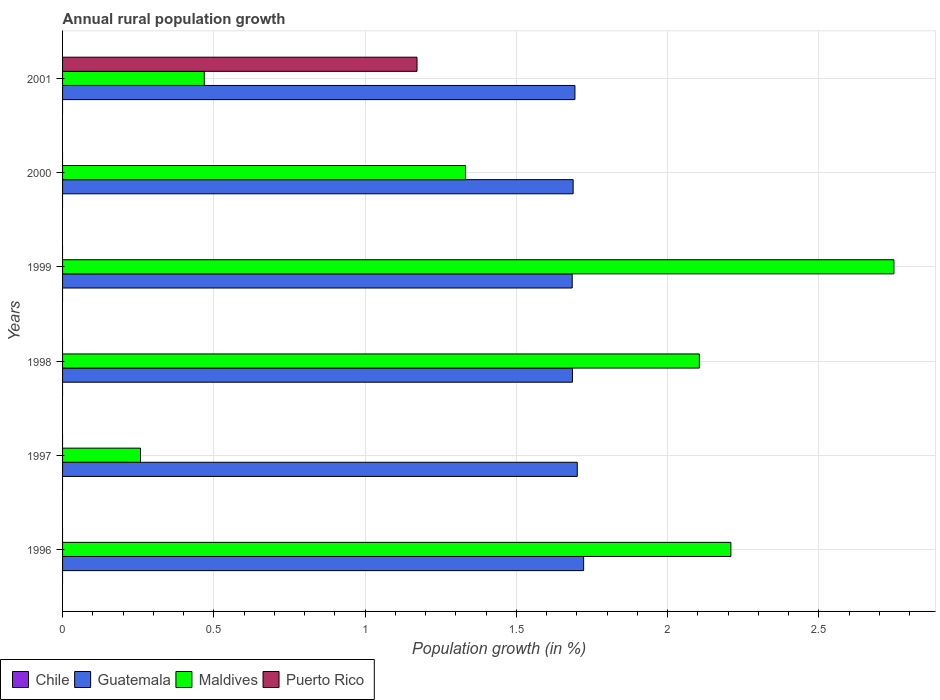How many different coloured bars are there?
Provide a succinct answer. 3. How many bars are there on the 5th tick from the top?
Ensure brevity in your answer.  2. How many bars are there on the 1st tick from the bottom?
Your answer should be very brief. 2. In how many cases, is the number of bars for a given year not equal to the number of legend labels?
Your response must be concise. 6. Across all years, what is the maximum percentage of rural population growth in Maldives?
Provide a short and direct response. 2.75. Across all years, what is the minimum percentage of rural population growth in Chile?
Your response must be concise. 0. In which year was the percentage of rural population growth in Puerto Rico maximum?
Your answer should be very brief. 2001. What is the total percentage of rural population growth in Guatemala in the graph?
Ensure brevity in your answer.  10.18. What is the difference between the percentage of rural population growth in Guatemala in 1997 and that in 1998?
Make the answer very short. 0.02. What is the difference between the percentage of rural population growth in Puerto Rico in 1996 and the percentage of rural population growth in Guatemala in 1999?
Your response must be concise. -1.68. What is the average percentage of rural population growth in Puerto Rico per year?
Your response must be concise. 0.2. In the year 1997, what is the difference between the percentage of rural population growth in Guatemala and percentage of rural population growth in Maldives?
Provide a succinct answer. 1.44. In how many years, is the percentage of rural population growth in Chile greater than 2.1 %?
Your answer should be very brief. 0. What is the ratio of the percentage of rural population growth in Maldives in 1996 to that in 1998?
Ensure brevity in your answer.  1.05. Is the percentage of rural population growth in Maldives in 1996 less than that in 1997?
Offer a terse response. No. Is the difference between the percentage of rural population growth in Guatemala in 1996 and 1998 greater than the difference between the percentage of rural population growth in Maldives in 1996 and 1998?
Your answer should be very brief. No. What is the difference between the highest and the second highest percentage of rural population growth in Guatemala?
Your answer should be compact. 0.02. What is the difference between the highest and the lowest percentage of rural population growth in Guatemala?
Make the answer very short. 0.04. Is the sum of the percentage of rural population growth in Guatemala in 1998 and 2001 greater than the maximum percentage of rural population growth in Puerto Rico across all years?
Offer a very short reply. Yes. Is it the case that in every year, the sum of the percentage of rural population growth in Chile and percentage of rural population growth in Maldives is greater than the sum of percentage of rural population growth in Guatemala and percentage of rural population growth in Puerto Rico?
Offer a very short reply. No. Are all the bars in the graph horizontal?
Keep it short and to the point. Yes. Are the values on the major ticks of X-axis written in scientific E-notation?
Provide a succinct answer. No. Does the graph contain any zero values?
Give a very brief answer. Yes. Does the graph contain grids?
Offer a very short reply. Yes. Where does the legend appear in the graph?
Offer a terse response. Bottom left. What is the title of the graph?
Your answer should be compact. Annual rural population growth. Does "Middle East & North Africa (developing only)" appear as one of the legend labels in the graph?
Keep it short and to the point. No. What is the label or title of the X-axis?
Keep it short and to the point. Population growth (in %). What is the label or title of the Y-axis?
Keep it short and to the point. Years. What is the Population growth (in %) of Guatemala in 1996?
Your answer should be very brief. 1.72. What is the Population growth (in %) in Maldives in 1996?
Make the answer very short. 2.21. What is the Population growth (in %) of Chile in 1997?
Your response must be concise. 0. What is the Population growth (in %) in Guatemala in 1997?
Your answer should be very brief. 1.7. What is the Population growth (in %) of Maldives in 1997?
Make the answer very short. 0.26. What is the Population growth (in %) of Puerto Rico in 1997?
Offer a very short reply. 0. What is the Population growth (in %) in Guatemala in 1998?
Provide a succinct answer. 1.69. What is the Population growth (in %) in Maldives in 1998?
Provide a succinct answer. 2.11. What is the Population growth (in %) in Chile in 1999?
Provide a succinct answer. 0. What is the Population growth (in %) of Guatemala in 1999?
Your answer should be very brief. 1.68. What is the Population growth (in %) of Maldives in 1999?
Give a very brief answer. 2.75. What is the Population growth (in %) of Puerto Rico in 1999?
Ensure brevity in your answer.  0. What is the Population growth (in %) of Guatemala in 2000?
Provide a short and direct response. 1.69. What is the Population growth (in %) of Maldives in 2000?
Offer a very short reply. 1.33. What is the Population growth (in %) in Puerto Rico in 2000?
Offer a terse response. 0. What is the Population growth (in %) in Chile in 2001?
Offer a very short reply. 0. What is the Population growth (in %) in Guatemala in 2001?
Provide a succinct answer. 1.69. What is the Population growth (in %) of Maldives in 2001?
Provide a short and direct response. 0.47. What is the Population growth (in %) of Puerto Rico in 2001?
Keep it short and to the point. 1.17. Across all years, what is the maximum Population growth (in %) in Guatemala?
Provide a short and direct response. 1.72. Across all years, what is the maximum Population growth (in %) of Maldives?
Ensure brevity in your answer.  2.75. Across all years, what is the maximum Population growth (in %) of Puerto Rico?
Make the answer very short. 1.17. Across all years, what is the minimum Population growth (in %) in Guatemala?
Ensure brevity in your answer.  1.68. Across all years, what is the minimum Population growth (in %) of Maldives?
Give a very brief answer. 0.26. What is the total Population growth (in %) of Chile in the graph?
Offer a terse response. 0. What is the total Population growth (in %) of Guatemala in the graph?
Ensure brevity in your answer.  10.18. What is the total Population growth (in %) of Maldives in the graph?
Ensure brevity in your answer.  9.12. What is the total Population growth (in %) in Puerto Rico in the graph?
Provide a succinct answer. 1.17. What is the difference between the Population growth (in %) in Guatemala in 1996 and that in 1997?
Offer a very short reply. 0.02. What is the difference between the Population growth (in %) in Maldives in 1996 and that in 1997?
Keep it short and to the point. 1.95. What is the difference between the Population growth (in %) of Guatemala in 1996 and that in 1998?
Your answer should be compact. 0.04. What is the difference between the Population growth (in %) of Maldives in 1996 and that in 1998?
Offer a terse response. 0.1. What is the difference between the Population growth (in %) in Guatemala in 1996 and that in 1999?
Your answer should be very brief. 0.04. What is the difference between the Population growth (in %) of Maldives in 1996 and that in 1999?
Offer a very short reply. -0.54. What is the difference between the Population growth (in %) in Guatemala in 1996 and that in 2000?
Your answer should be very brief. 0.03. What is the difference between the Population growth (in %) in Maldives in 1996 and that in 2000?
Your answer should be compact. 0.88. What is the difference between the Population growth (in %) in Guatemala in 1996 and that in 2001?
Offer a very short reply. 0.03. What is the difference between the Population growth (in %) in Maldives in 1996 and that in 2001?
Your answer should be compact. 1.74. What is the difference between the Population growth (in %) of Guatemala in 1997 and that in 1998?
Your answer should be very brief. 0.02. What is the difference between the Population growth (in %) in Maldives in 1997 and that in 1998?
Keep it short and to the point. -1.85. What is the difference between the Population growth (in %) of Guatemala in 1997 and that in 1999?
Offer a very short reply. 0.02. What is the difference between the Population growth (in %) of Maldives in 1997 and that in 1999?
Your response must be concise. -2.49. What is the difference between the Population growth (in %) of Guatemala in 1997 and that in 2000?
Give a very brief answer. 0.01. What is the difference between the Population growth (in %) in Maldives in 1997 and that in 2000?
Keep it short and to the point. -1.07. What is the difference between the Population growth (in %) of Guatemala in 1997 and that in 2001?
Offer a terse response. 0.01. What is the difference between the Population growth (in %) of Maldives in 1997 and that in 2001?
Provide a short and direct response. -0.21. What is the difference between the Population growth (in %) of Guatemala in 1998 and that in 1999?
Provide a succinct answer. 0. What is the difference between the Population growth (in %) of Maldives in 1998 and that in 1999?
Keep it short and to the point. -0.64. What is the difference between the Population growth (in %) in Guatemala in 1998 and that in 2000?
Your answer should be compact. -0. What is the difference between the Population growth (in %) of Maldives in 1998 and that in 2000?
Keep it short and to the point. 0.77. What is the difference between the Population growth (in %) in Guatemala in 1998 and that in 2001?
Your response must be concise. -0.01. What is the difference between the Population growth (in %) in Maldives in 1998 and that in 2001?
Your answer should be very brief. 1.64. What is the difference between the Population growth (in %) in Guatemala in 1999 and that in 2000?
Provide a succinct answer. -0. What is the difference between the Population growth (in %) of Maldives in 1999 and that in 2000?
Provide a short and direct response. 1.42. What is the difference between the Population growth (in %) in Guatemala in 1999 and that in 2001?
Offer a very short reply. -0.01. What is the difference between the Population growth (in %) in Maldives in 1999 and that in 2001?
Ensure brevity in your answer.  2.28. What is the difference between the Population growth (in %) of Guatemala in 2000 and that in 2001?
Offer a very short reply. -0.01. What is the difference between the Population growth (in %) in Maldives in 2000 and that in 2001?
Your answer should be very brief. 0.86. What is the difference between the Population growth (in %) of Guatemala in 1996 and the Population growth (in %) of Maldives in 1997?
Offer a terse response. 1.47. What is the difference between the Population growth (in %) of Guatemala in 1996 and the Population growth (in %) of Maldives in 1998?
Give a very brief answer. -0.38. What is the difference between the Population growth (in %) of Guatemala in 1996 and the Population growth (in %) of Maldives in 1999?
Your response must be concise. -1.03. What is the difference between the Population growth (in %) of Guatemala in 1996 and the Population growth (in %) of Maldives in 2000?
Ensure brevity in your answer.  0.39. What is the difference between the Population growth (in %) in Guatemala in 1996 and the Population growth (in %) in Maldives in 2001?
Provide a succinct answer. 1.25. What is the difference between the Population growth (in %) in Guatemala in 1996 and the Population growth (in %) in Puerto Rico in 2001?
Give a very brief answer. 0.55. What is the difference between the Population growth (in %) of Maldives in 1996 and the Population growth (in %) of Puerto Rico in 2001?
Your response must be concise. 1.04. What is the difference between the Population growth (in %) of Guatemala in 1997 and the Population growth (in %) of Maldives in 1998?
Your response must be concise. -0.4. What is the difference between the Population growth (in %) of Guatemala in 1997 and the Population growth (in %) of Maldives in 1999?
Your answer should be compact. -1.05. What is the difference between the Population growth (in %) of Guatemala in 1997 and the Population growth (in %) of Maldives in 2000?
Provide a succinct answer. 0.37. What is the difference between the Population growth (in %) of Guatemala in 1997 and the Population growth (in %) of Maldives in 2001?
Offer a very short reply. 1.23. What is the difference between the Population growth (in %) in Guatemala in 1997 and the Population growth (in %) in Puerto Rico in 2001?
Keep it short and to the point. 0.53. What is the difference between the Population growth (in %) in Maldives in 1997 and the Population growth (in %) in Puerto Rico in 2001?
Give a very brief answer. -0.91. What is the difference between the Population growth (in %) of Guatemala in 1998 and the Population growth (in %) of Maldives in 1999?
Your response must be concise. -1.06. What is the difference between the Population growth (in %) of Guatemala in 1998 and the Population growth (in %) of Maldives in 2000?
Your response must be concise. 0.35. What is the difference between the Population growth (in %) in Guatemala in 1998 and the Population growth (in %) in Maldives in 2001?
Your response must be concise. 1.22. What is the difference between the Population growth (in %) of Guatemala in 1998 and the Population growth (in %) of Puerto Rico in 2001?
Your answer should be very brief. 0.51. What is the difference between the Population growth (in %) in Maldives in 1998 and the Population growth (in %) in Puerto Rico in 2001?
Offer a very short reply. 0.93. What is the difference between the Population growth (in %) of Guatemala in 1999 and the Population growth (in %) of Maldives in 2000?
Offer a very short reply. 0.35. What is the difference between the Population growth (in %) in Guatemala in 1999 and the Population growth (in %) in Maldives in 2001?
Offer a very short reply. 1.22. What is the difference between the Population growth (in %) of Guatemala in 1999 and the Population growth (in %) of Puerto Rico in 2001?
Your response must be concise. 0.51. What is the difference between the Population growth (in %) of Maldives in 1999 and the Population growth (in %) of Puerto Rico in 2001?
Provide a short and direct response. 1.58. What is the difference between the Population growth (in %) in Guatemala in 2000 and the Population growth (in %) in Maldives in 2001?
Make the answer very short. 1.22. What is the difference between the Population growth (in %) in Guatemala in 2000 and the Population growth (in %) in Puerto Rico in 2001?
Provide a succinct answer. 0.52. What is the difference between the Population growth (in %) of Maldives in 2000 and the Population growth (in %) of Puerto Rico in 2001?
Provide a succinct answer. 0.16. What is the average Population growth (in %) of Guatemala per year?
Make the answer very short. 1.7. What is the average Population growth (in %) in Maldives per year?
Offer a very short reply. 1.52. What is the average Population growth (in %) of Puerto Rico per year?
Provide a short and direct response. 0.2. In the year 1996, what is the difference between the Population growth (in %) in Guatemala and Population growth (in %) in Maldives?
Provide a succinct answer. -0.49. In the year 1997, what is the difference between the Population growth (in %) in Guatemala and Population growth (in %) in Maldives?
Provide a succinct answer. 1.44. In the year 1998, what is the difference between the Population growth (in %) in Guatemala and Population growth (in %) in Maldives?
Offer a very short reply. -0.42. In the year 1999, what is the difference between the Population growth (in %) of Guatemala and Population growth (in %) of Maldives?
Offer a very short reply. -1.06. In the year 2000, what is the difference between the Population growth (in %) of Guatemala and Population growth (in %) of Maldives?
Your answer should be compact. 0.36. In the year 2001, what is the difference between the Population growth (in %) in Guatemala and Population growth (in %) in Maldives?
Ensure brevity in your answer.  1.23. In the year 2001, what is the difference between the Population growth (in %) in Guatemala and Population growth (in %) in Puerto Rico?
Your answer should be very brief. 0.52. In the year 2001, what is the difference between the Population growth (in %) in Maldives and Population growth (in %) in Puerto Rico?
Offer a very short reply. -0.7. What is the ratio of the Population growth (in %) in Guatemala in 1996 to that in 1997?
Provide a short and direct response. 1.01. What is the ratio of the Population growth (in %) in Maldives in 1996 to that in 1997?
Keep it short and to the point. 8.58. What is the ratio of the Population growth (in %) of Guatemala in 1996 to that in 1998?
Offer a terse response. 1.02. What is the ratio of the Population growth (in %) of Maldives in 1996 to that in 1998?
Offer a terse response. 1.05. What is the ratio of the Population growth (in %) in Guatemala in 1996 to that in 1999?
Provide a succinct answer. 1.02. What is the ratio of the Population growth (in %) of Maldives in 1996 to that in 1999?
Keep it short and to the point. 0.8. What is the ratio of the Population growth (in %) in Guatemala in 1996 to that in 2000?
Your response must be concise. 1.02. What is the ratio of the Population growth (in %) in Maldives in 1996 to that in 2000?
Keep it short and to the point. 1.66. What is the ratio of the Population growth (in %) in Maldives in 1996 to that in 2001?
Your answer should be very brief. 4.72. What is the ratio of the Population growth (in %) in Guatemala in 1997 to that in 1998?
Provide a short and direct response. 1.01. What is the ratio of the Population growth (in %) of Maldives in 1997 to that in 1998?
Your answer should be compact. 0.12. What is the ratio of the Population growth (in %) of Guatemala in 1997 to that in 1999?
Keep it short and to the point. 1.01. What is the ratio of the Population growth (in %) of Maldives in 1997 to that in 1999?
Provide a short and direct response. 0.09. What is the ratio of the Population growth (in %) in Maldives in 1997 to that in 2000?
Offer a terse response. 0.19. What is the ratio of the Population growth (in %) in Maldives in 1997 to that in 2001?
Keep it short and to the point. 0.55. What is the ratio of the Population growth (in %) of Guatemala in 1998 to that in 1999?
Provide a short and direct response. 1. What is the ratio of the Population growth (in %) in Maldives in 1998 to that in 1999?
Your answer should be very brief. 0.77. What is the ratio of the Population growth (in %) of Maldives in 1998 to that in 2000?
Offer a very short reply. 1.58. What is the ratio of the Population growth (in %) in Guatemala in 1998 to that in 2001?
Your answer should be very brief. 1. What is the ratio of the Population growth (in %) in Maldives in 1998 to that in 2001?
Your response must be concise. 4.49. What is the ratio of the Population growth (in %) in Guatemala in 1999 to that in 2000?
Provide a short and direct response. 1. What is the ratio of the Population growth (in %) in Maldives in 1999 to that in 2000?
Your answer should be compact. 2.06. What is the ratio of the Population growth (in %) in Guatemala in 1999 to that in 2001?
Your answer should be very brief. 0.99. What is the ratio of the Population growth (in %) of Maldives in 1999 to that in 2001?
Make the answer very short. 5.87. What is the ratio of the Population growth (in %) in Guatemala in 2000 to that in 2001?
Your answer should be very brief. 1. What is the ratio of the Population growth (in %) of Maldives in 2000 to that in 2001?
Your response must be concise. 2.84. What is the difference between the highest and the second highest Population growth (in %) in Guatemala?
Ensure brevity in your answer.  0.02. What is the difference between the highest and the second highest Population growth (in %) in Maldives?
Offer a terse response. 0.54. What is the difference between the highest and the lowest Population growth (in %) in Guatemala?
Provide a succinct answer. 0.04. What is the difference between the highest and the lowest Population growth (in %) in Maldives?
Ensure brevity in your answer.  2.49. What is the difference between the highest and the lowest Population growth (in %) in Puerto Rico?
Offer a very short reply. 1.17. 